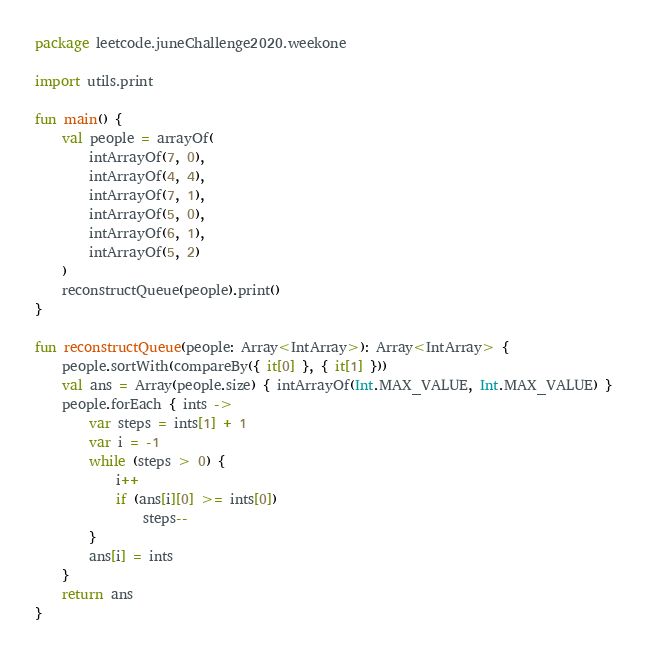Convert code to text. <code><loc_0><loc_0><loc_500><loc_500><_Kotlin_>package leetcode.juneChallenge2020.weekone

import utils.print

fun main() {
    val people = arrayOf(
        intArrayOf(7, 0),
        intArrayOf(4, 4),
        intArrayOf(7, 1),
        intArrayOf(5, 0),
        intArrayOf(6, 1),
        intArrayOf(5, 2)
    )
    reconstructQueue(people).print()
}

fun reconstructQueue(people: Array<IntArray>): Array<IntArray> {
    people.sortWith(compareBy({ it[0] }, { it[1] }))
    val ans = Array(people.size) { intArrayOf(Int.MAX_VALUE, Int.MAX_VALUE) }
    people.forEach { ints ->
        var steps = ints[1] + 1
        var i = -1
        while (steps > 0) {
            i++
            if (ans[i][0] >= ints[0])
                steps--
        }
        ans[i] = ints
    }
    return ans
}</code> 